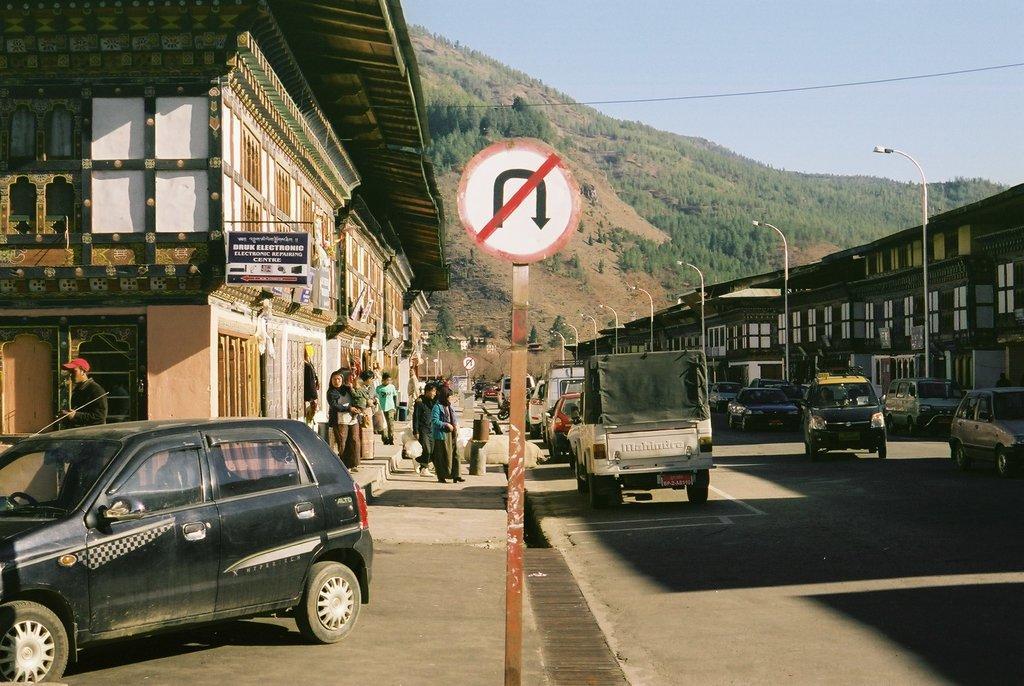Describe this image in one or two sentences. In the image we can see there are many vehicles on the road. There are even people standing and wearing clothes. Here we can see poles and a sign board. There are even light poles, buildings and these are the windows of the buildings. Here we can see mountains, trees, electric wire and a sky. 